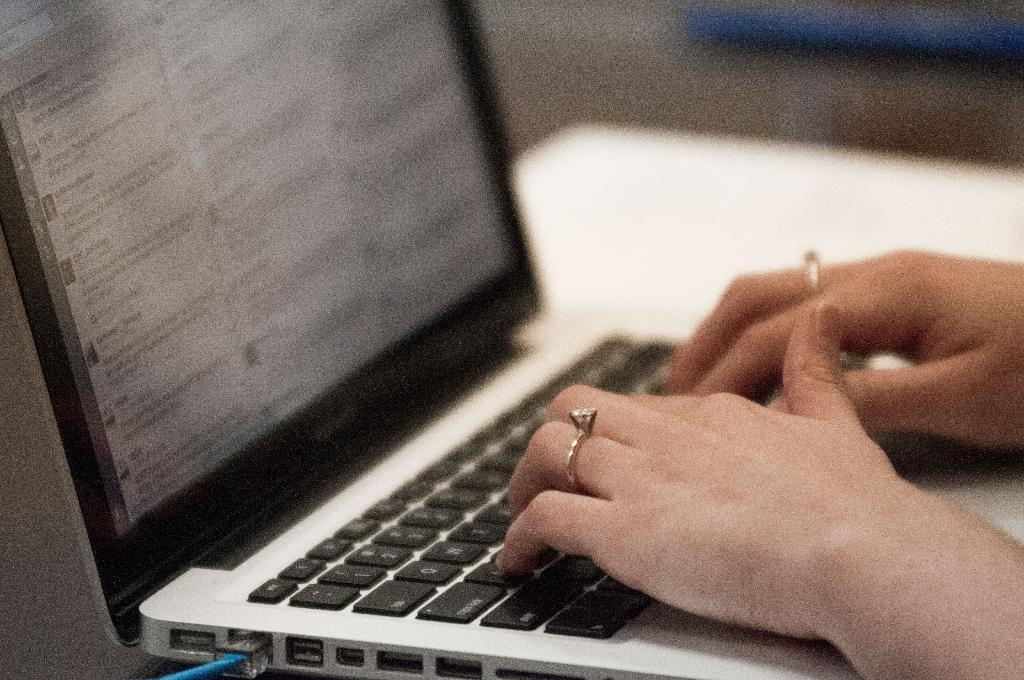<image>
Share a concise interpretation of the image provided. Person typing on a black and silver laptop with an ESC key on the top left. 